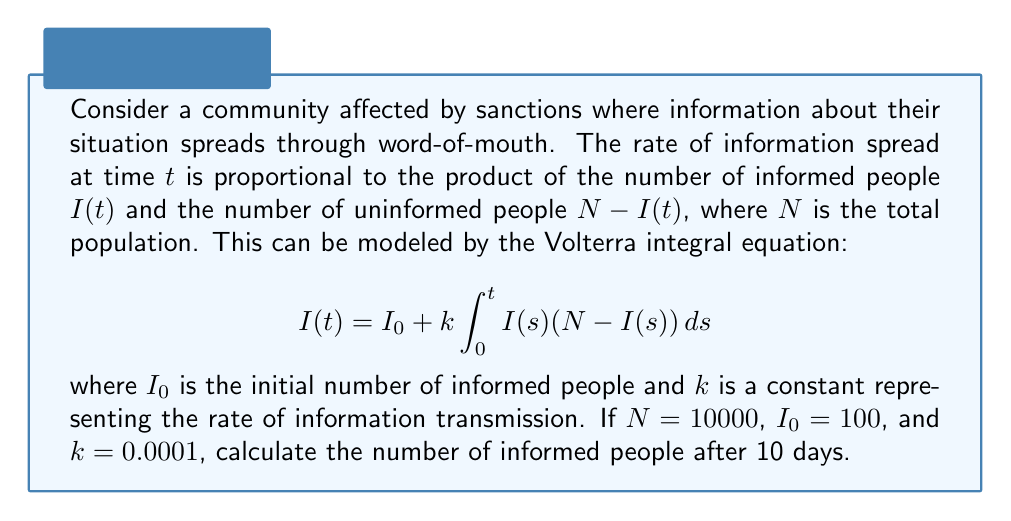Teach me how to tackle this problem. To solve this Volterra integral equation, we'll use a numerical method called Euler's method. We'll divide the time interval into small steps and approximate the solution iteratively.

Step 1: Set up the parameters
- $N = 10000$
- $I_0 = 100$
- $k = 0.0001$
- Time interval: 0 to 10 days
- Let's use a step size of 0.1 days, so we have 100 steps

Step 2: Initialize the solution array
Let $I[i]$ represent $I(t_i)$ where $t_i = i \cdot 0.1$
$I[0] = I_0 = 100$

Step 3: Apply Euler's method
For $i = 1$ to $100$:
$$I[i] = I[i-1] + 0.1 \cdot k \cdot I[i-1] \cdot (N - I[i-1])$$

Step 4: Implement the method (pseudo-code)
```
for i = 1 to 100:
    I[i] = I[i-1] + 0.1 * 0.0001 * I[i-1] * (10000 - I[i-1])
```

Step 5: Calculate the final value
After running the loop, $I[100]$ will give us the approximate number of informed people after 10 days.

The result of this calculation is approximately 9839.

Note: This is an approximation. More accurate results can be obtained by using smaller step sizes or more advanced numerical methods.
Answer: 9839 people 